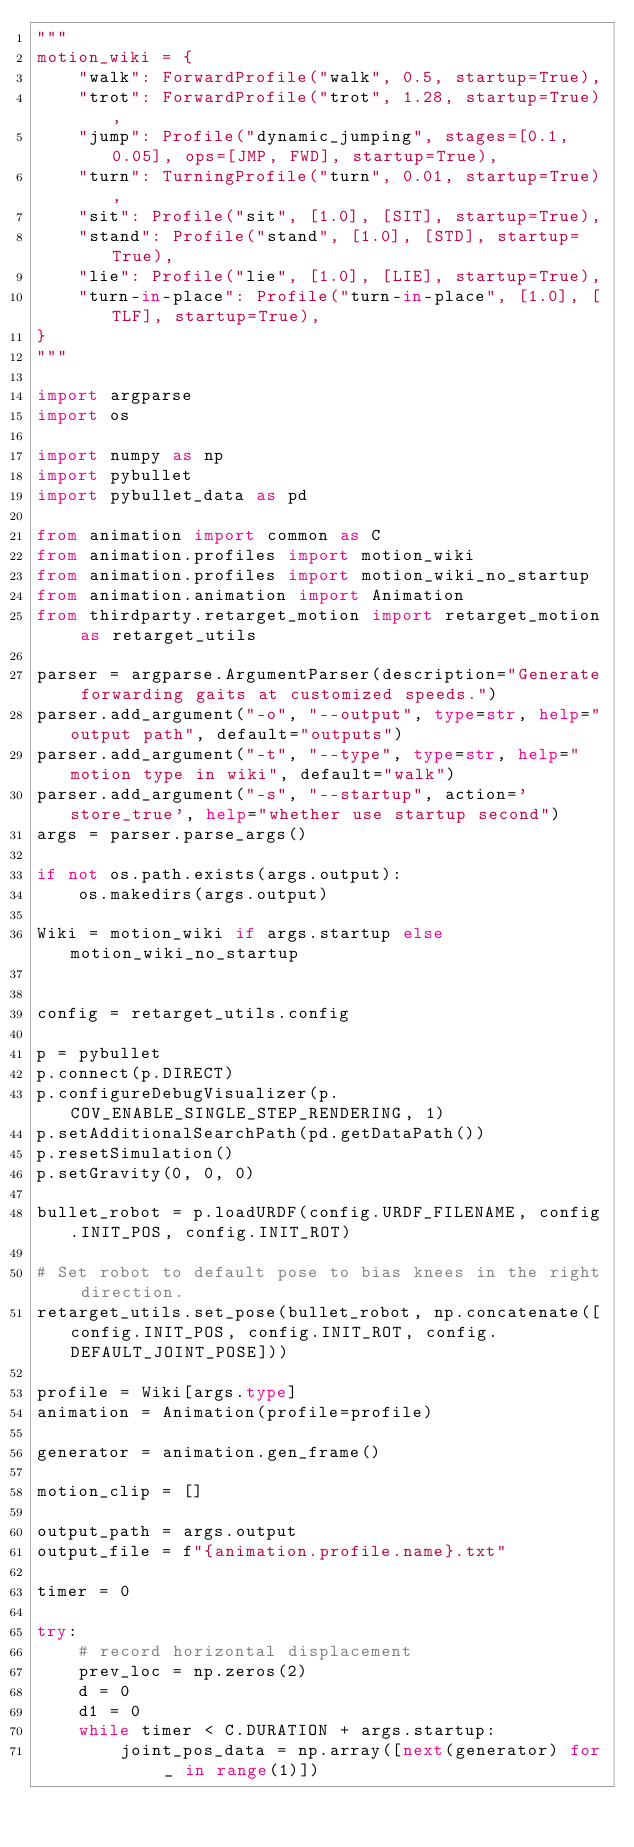Convert code to text. <code><loc_0><loc_0><loc_500><loc_500><_Python_>"""
motion_wiki = {
    "walk": ForwardProfile("walk", 0.5, startup=True),
    "trot": ForwardProfile("trot", 1.28, startup=True),
    "jump": Profile("dynamic_jumping", stages=[0.1, 0.05], ops=[JMP, FWD], startup=True),
    "turn": TurningProfile("turn", 0.01, startup=True),
    "sit": Profile("sit", [1.0], [SIT], startup=True),
    "stand": Profile("stand", [1.0], [STD], startup=True),
    "lie": Profile("lie", [1.0], [LIE], startup=True),
    "turn-in-place": Profile("turn-in-place", [1.0], [TLF], startup=True),
}
"""

import argparse
import os

import numpy as np
import pybullet
import pybullet_data as pd

from animation import common as C
from animation.profiles import motion_wiki
from animation.profiles import motion_wiki_no_startup 
from animation.animation import Animation
from thirdparty.retarget_motion import retarget_motion as retarget_utils

parser = argparse.ArgumentParser(description="Generate forwarding gaits at customized speeds.")
parser.add_argument("-o", "--output", type=str, help="output path", default="outputs")
parser.add_argument("-t", "--type", type=str, help="motion type in wiki", default="walk")
parser.add_argument("-s", "--startup", action='store_true', help="whether use startup second")
args = parser.parse_args()

if not os.path.exists(args.output):
    os.makedirs(args.output)

Wiki = motion_wiki if args.startup else motion_wiki_no_startup


config = retarget_utils.config

p = pybullet
p.connect(p.DIRECT)
p.configureDebugVisualizer(p.COV_ENABLE_SINGLE_STEP_RENDERING, 1)
p.setAdditionalSearchPath(pd.getDataPath())
p.resetSimulation()
p.setGravity(0, 0, 0)

bullet_robot = p.loadURDF(config.URDF_FILENAME, config.INIT_POS, config.INIT_ROT)

# Set robot to default pose to bias knees in the right direction.
retarget_utils.set_pose(bullet_robot, np.concatenate([config.INIT_POS, config.INIT_ROT, config.DEFAULT_JOINT_POSE]))

profile = Wiki[args.type]
animation = Animation(profile=profile)

generator = animation.gen_frame()

motion_clip = []

output_path = args.output
output_file = f"{animation.profile.name}.txt"

timer = 0

try:
    # record horizontal displacement
    prev_loc = np.zeros(2)
    d = 0
    d1 = 0
    while timer < C.DURATION + args.startup:
        joint_pos_data = np.array([next(generator) for _ in range(1)])
</code> 